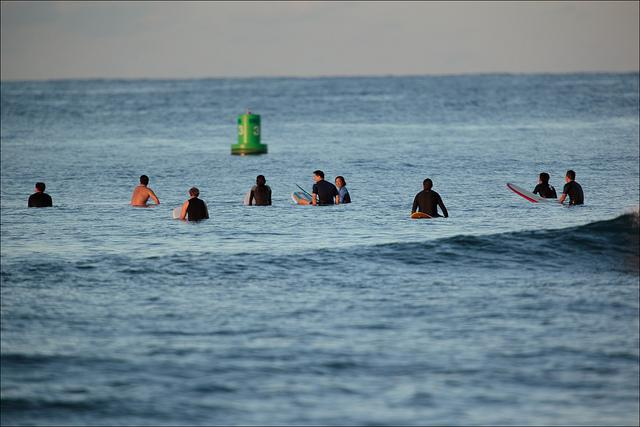Where are the people hanging out? ocean 